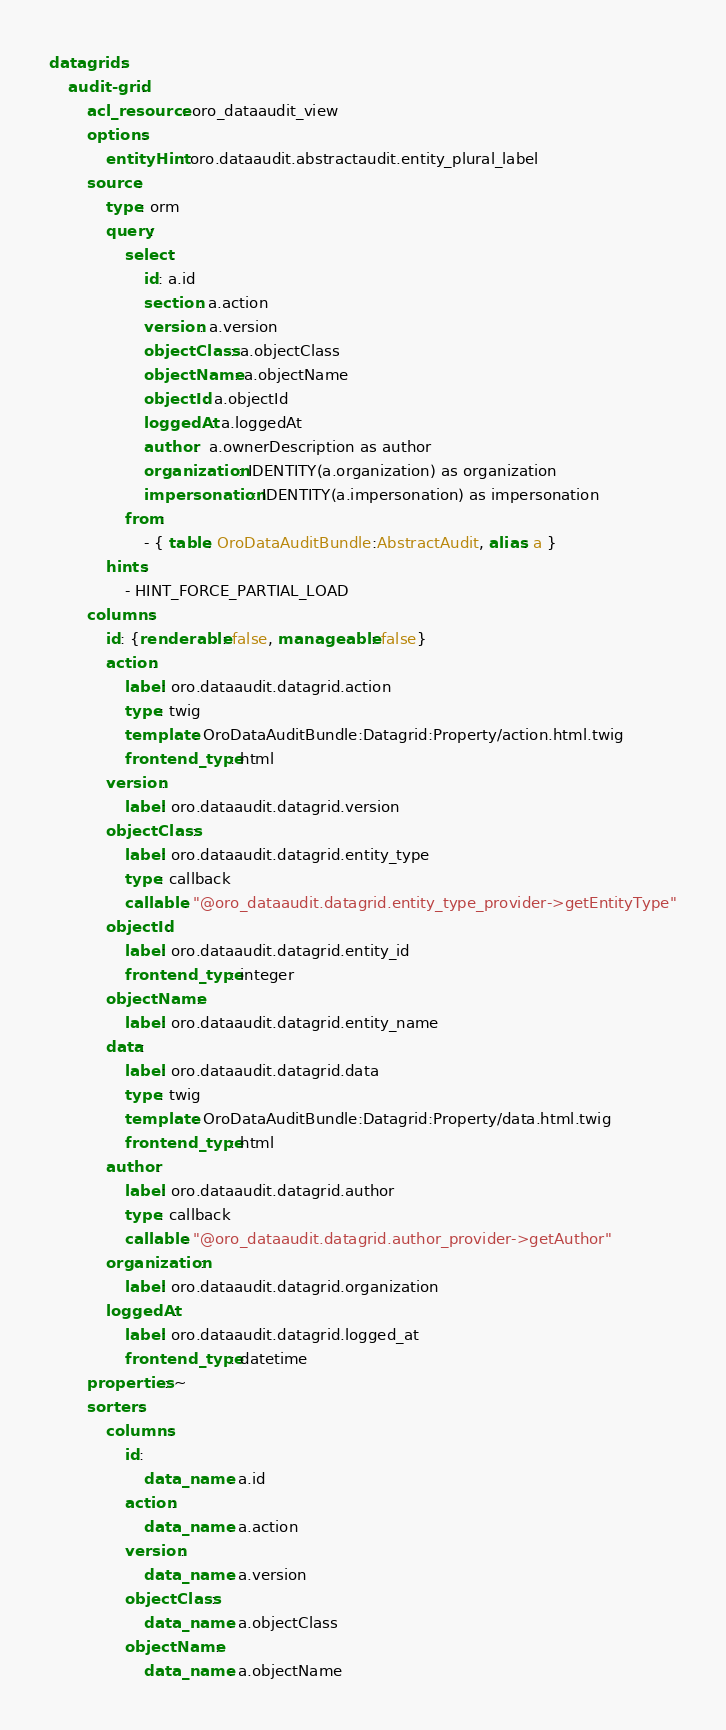<code> <loc_0><loc_0><loc_500><loc_500><_YAML_>datagrids:
    audit-grid:
        acl_resource: oro_dataaudit_view
        options:
            entityHint: oro.dataaudit.abstractaudit.entity_plural_label
        source:
            type: orm
            query:
                select:
                    id: a.id
                    section: a.action
                    version: a.version
                    objectClass: a.objectClass
                    objectName: a.objectName
                    objectId: a.objectId
                    loggedAt: a.loggedAt
                    author:  a.ownerDescription as author
                    organization: IDENTITY(a.organization) as organization
                    impersonation: IDENTITY(a.impersonation) as impersonation
                from:
                    - { table: OroDataAuditBundle:AbstractAudit, alias: a }
            hints:
                - HINT_FORCE_PARTIAL_LOAD
        columns:
            id: {renderable: false, manageable: false}
            action:
                label: oro.dataaudit.datagrid.action
                type: twig
                template: OroDataAuditBundle:Datagrid:Property/action.html.twig
                frontend_type: html
            version:
                label: oro.dataaudit.datagrid.version
            objectClass:
                label: oro.dataaudit.datagrid.entity_type
                type: callback
                callable: "@oro_dataaudit.datagrid.entity_type_provider->getEntityType"
            objectId:
                label: oro.dataaudit.datagrid.entity_id
                frontend_type: integer
            objectName:
                label: oro.dataaudit.datagrid.entity_name
            data:
                label: oro.dataaudit.datagrid.data
                type: twig
                template: OroDataAuditBundle:Datagrid:Property/data.html.twig
                frontend_type: html
            author:
                label: oro.dataaudit.datagrid.author
                type: callback
                callable: "@oro_dataaudit.datagrid.author_provider->getAuthor"
            organization:
                label: oro.dataaudit.datagrid.organization
            loggedAt:
                label: oro.dataaudit.datagrid.logged_at
                frontend_type: datetime
        properties: ~
        sorters:
            columns:
                id:
                    data_name: a.id
                action:
                    data_name: a.action
                version:
                    data_name: a.version
                objectClass:
                    data_name: a.objectClass
                objectName:
                    data_name: a.objectName</code> 